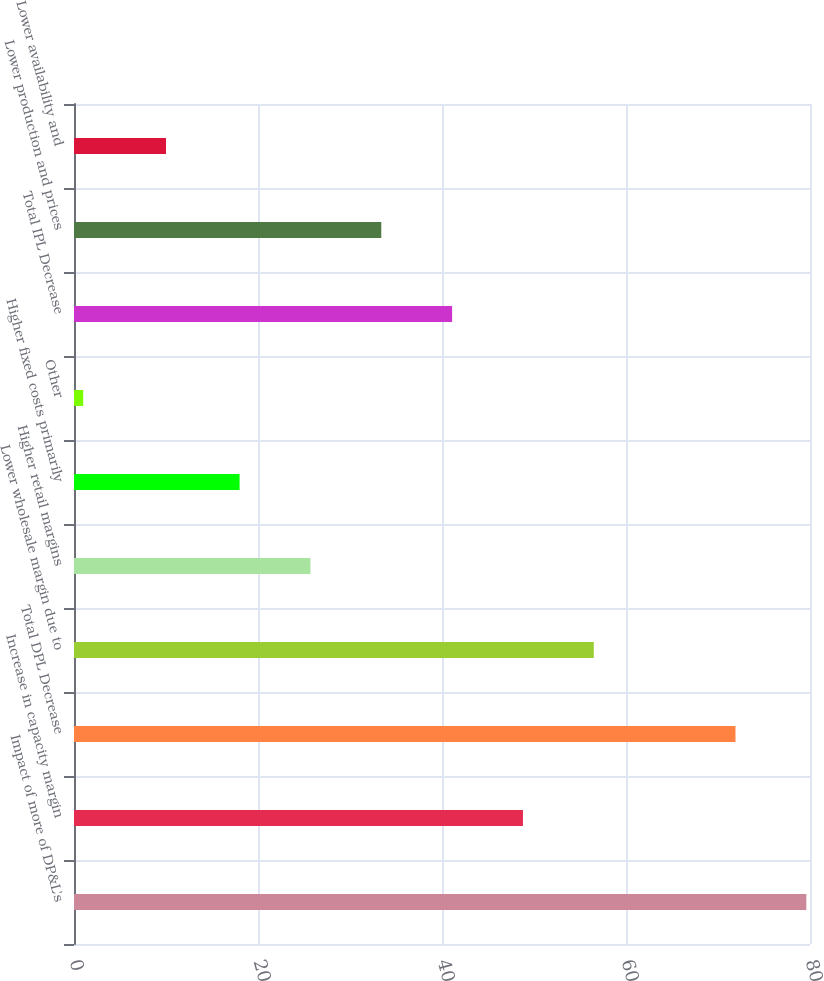Convert chart to OTSL. <chart><loc_0><loc_0><loc_500><loc_500><bar_chart><fcel>Impact of more of DP&L's<fcel>Increase in capacity margin<fcel>Total DPL Decrease<fcel>Lower wholesale margin due to<fcel>Higher retail margins<fcel>Higher fixed costs primarily<fcel>Other<fcel>Total IPL Decrease<fcel>Lower production and prices<fcel>Lower availability and<nl><fcel>79.6<fcel>48.8<fcel>71.9<fcel>56.5<fcel>25.7<fcel>18<fcel>1<fcel>41.1<fcel>33.4<fcel>10<nl></chart> 